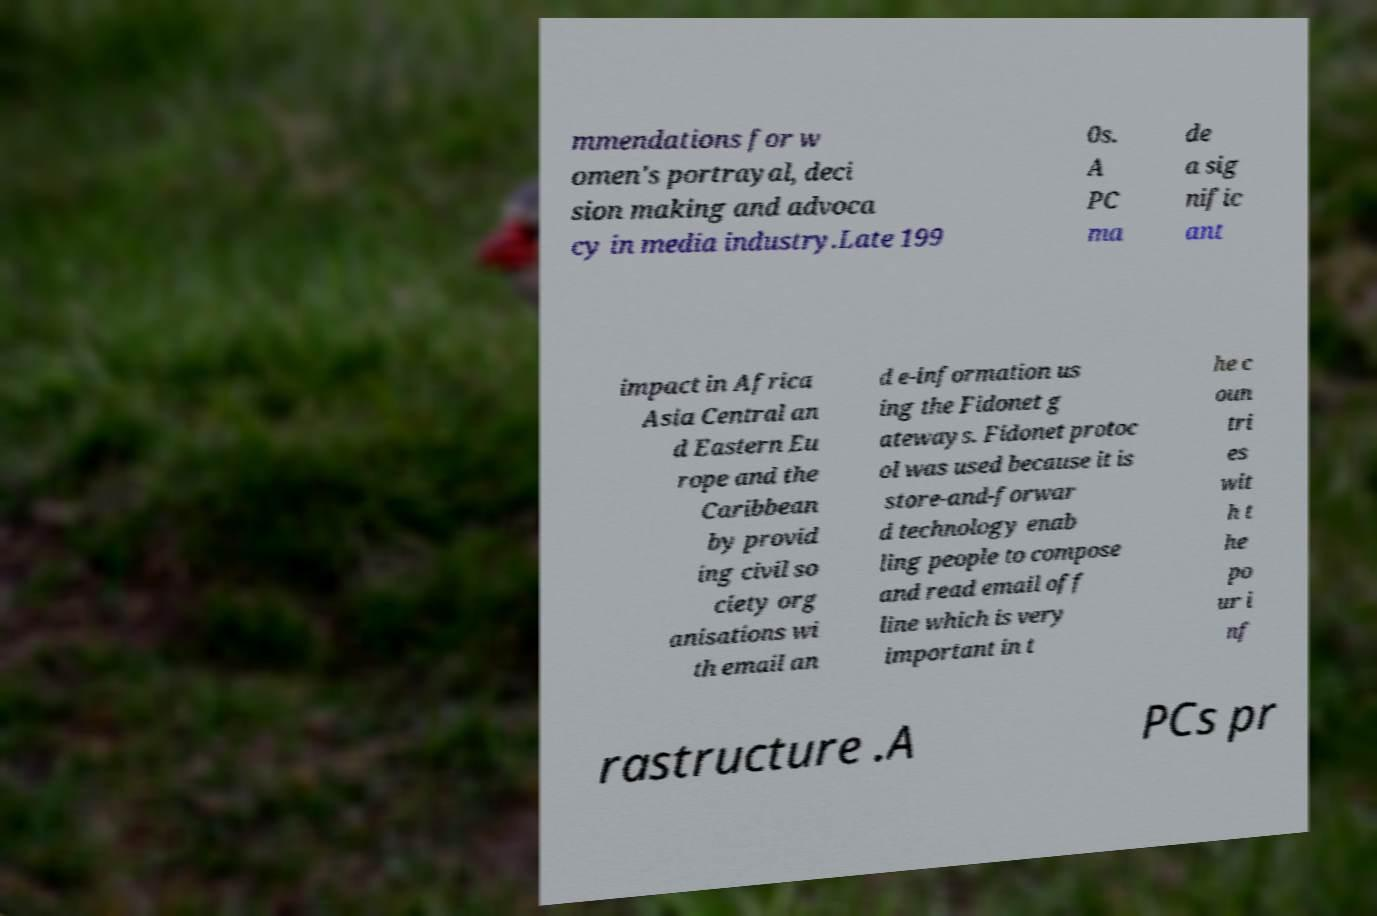I need the written content from this picture converted into text. Can you do that? mmendations for w omen's portrayal, deci sion making and advoca cy in media industry.Late 199 0s. A PC ma de a sig nific ant impact in Africa Asia Central an d Eastern Eu rope and the Caribbean by provid ing civil so ciety org anisations wi th email an d e-information us ing the Fidonet g ateways. Fidonet protoc ol was used because it is store-and-forwar d technology enab ling people to compose and read email off line which is very important in t he c oun tri es wit h t he po ur i nf rastructure .A PCs pr 